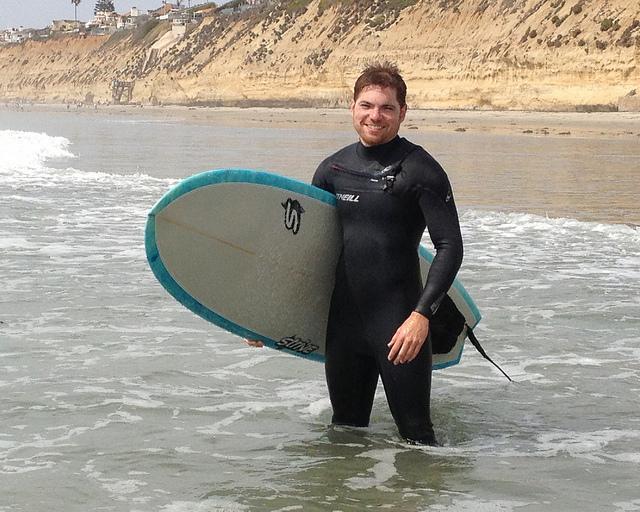How many surfboards are in the picture?
Give a very brief answer. 1. 